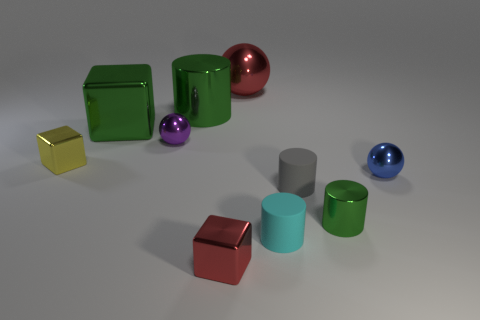Subtract all cylinders. How many objects are left? 6 Add 6 big green metallic things. How many big green metallic things are left? 8 Add 1 big purple matte blocks. How many big purple matte blocks exist? 1 Subtract 1 red cubes. How many objects are left? 9 Subtract all spheres. Subtract all large red balls. How many objects are left? 6 